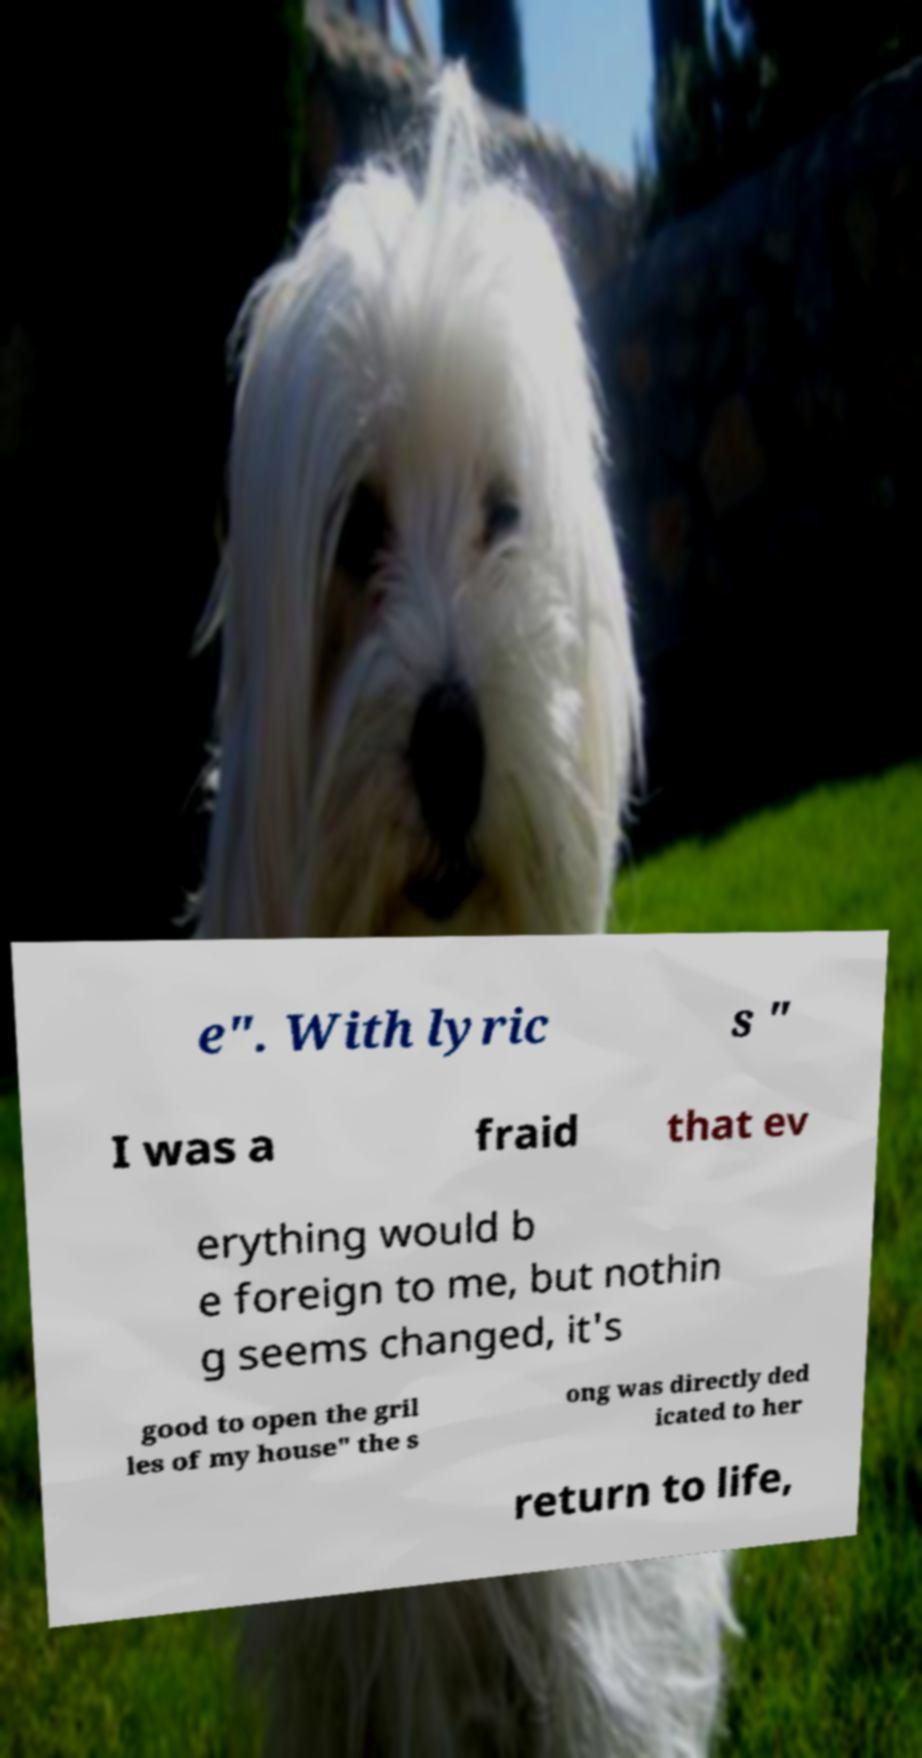There's text embedded in this image that I need extracted. Can you transcribe it verbatim? e". With lyric s " I was a fraid that ev erything would b e foreign to me, but nothin g seems changed, it's good to open the gril les of my house" the s ong was directly ded icated to her return to life, 